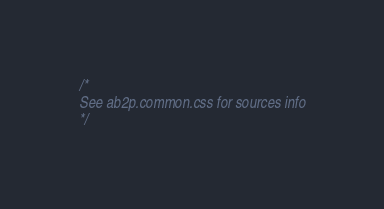Convert code to text. <code><loc_0><loc_0><loc_500><loc_500><_CSS_>/*
See ab2p.common.css for sources info
*/</code> 